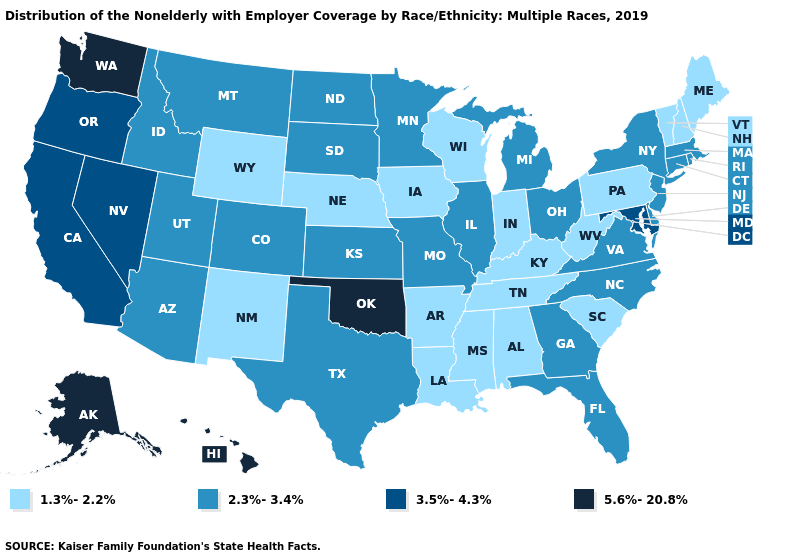What is the lowest value in states that border Wyoming?
Keep it brief. 1.3%-2.2%. What is the value of Nebraska?
Concise answer only. 1.3%-2.2%. Among the states that border Kentucky , which have the lowest value?
Quick response, please. Indiana, Tennessee, West Virginia. Name the states that have a value in the range 3.5%-4.3%?
Keep it brief. California, Maryland, Nevada, Oregon. Is the legend a continuous bar?
Quick response, please. No. Among the states that border Oregon , does Nevada have the highest value?
Give a very brief answer. No. What is the highest value in states that border Montana?
Give a very brief answer. 2.3%-3.4%. Does the first symbol in the legend represent the smallest category?
Keep it brief. Yes. Among the states that border Iowa , which have the lowest value?
Keep it brief. Nebraska, Wisconsin. Does the first symbol in the legend represent the smallest category?
Be succinct. Yes. Which states have the lowest value in the West?
Concise answer only. New Mexico, Wyoming. What is the value of Georgia?
Give a very brief answer. 2.3%-3.4%. Does Texas have the lowest value in the South?
Be succinct. No. How many symbols are there in the legend?
Concise answer only. 4. What is the value of Connecticut?
Keep it brief. 2.3%-3.4%. 